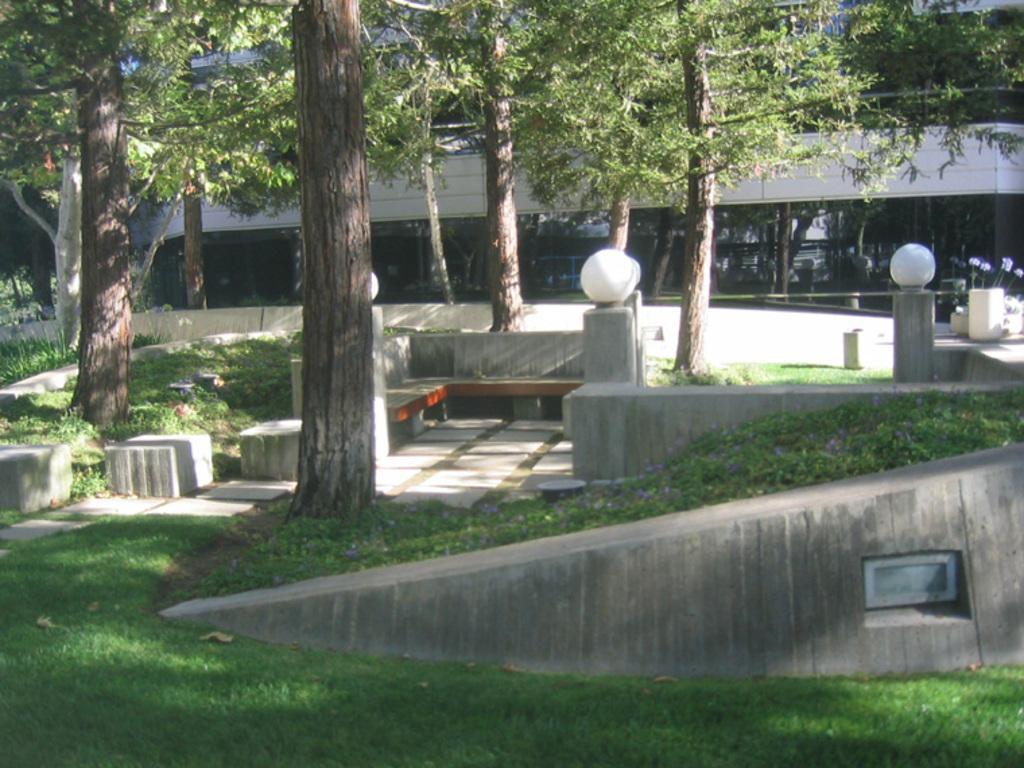Can you describe this image briefly? In this picture I can see a building and few trees and I can see lights and grass on the ground and few plants. 